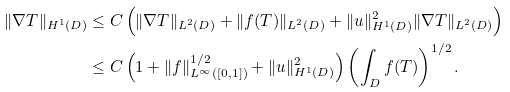Convert formula to latex. <formula><loc_0><loc_0><loc_500><loc_500>\| \nabla T \| _ { H ^ { 1 } ( D ) } & \leq C \left ( \| \nabla T \| _ { L ^ { 2 } ( D ) } + \| f ( T ) \| _ { L ^ { 2 } ( D ) } + \| u \| ^ { 2 } _ { H ^ { 1 } ( D ) } \| \nabla T \| _ { L ^ { 2 } ( D ) } \right ) \\ & \leq C \left ( 1 + \| f \| _ { L ^ { \infty } ( [ 0 , 1 ] ) } ^ { 1 / 2 } + \| u \| ^ { 2 } _ { H ^ { 1 } ( D ) } \right ) \left ( \int _ { D } f ( T ) \right ) ^ { 1 / 2 } .</formula> 